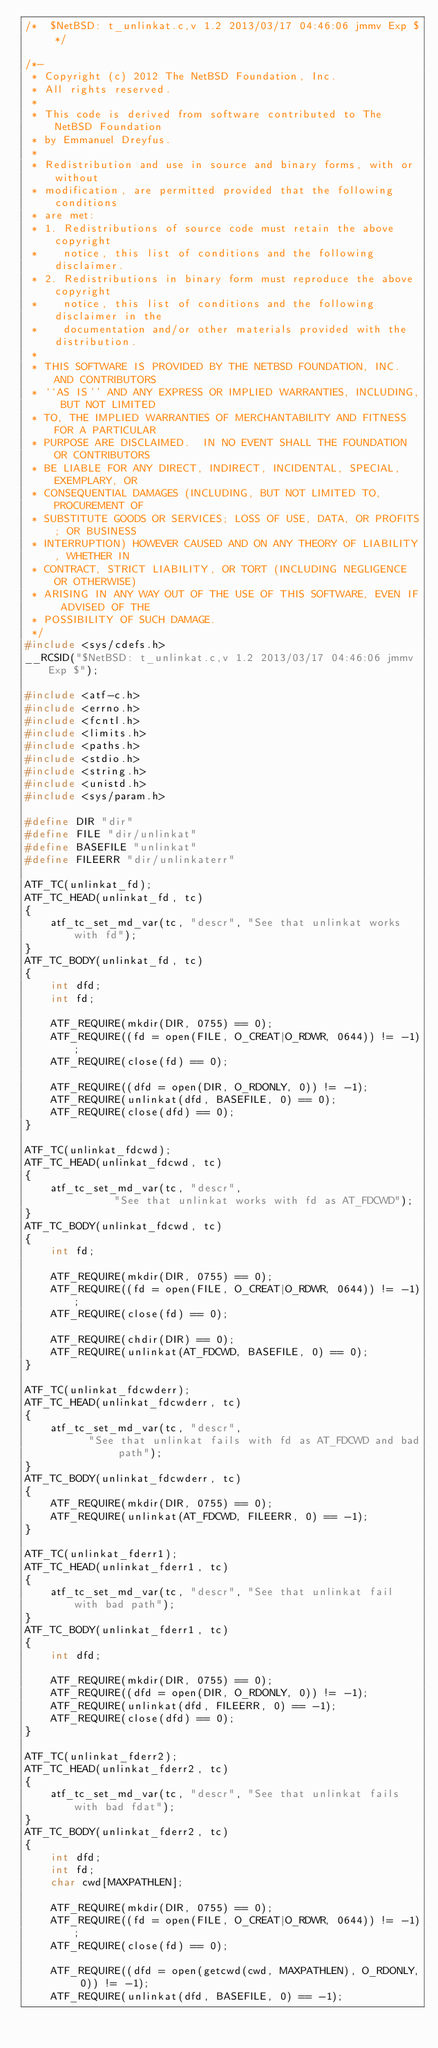<code> <loc_0><loc_0><loc_500><loc_500><_C_>/*	$NetBSD: t_unlinkat.c,v 1.2 2013/03/17 04:46:06 jmmv Exp $ */

/*-
 * Copyright (c) 2012 The NetBSD Foundation, Inc.
 * All rights reserved.
 *
 * This code is derived from software contributed to The NetBSD Foundation
 * by Emmanuel Dreyfus.
 *
 * Redistribution and use in source and binary forms, with or without
 * modification, are permitted provided that the following conditions
 * are met:
 * 1. Redistributions of source code must retain the above copyright
 *    notice, this list of conditions and the following disclaimer.
 * 2. Redistributions in binary form must reproduce the above copyright
 *    notice, this list of conditions and the following disclaimer in the
 *    documentation and/or other materials provided with the distribution.
 *
 * THIS SOFTWARE IS PROVIDED BY THE NETBSD FOUNDATION, INC. AND CONTRIBUTORS
 * ``AS IS'' AND ANY EXPRESS OR IMPLIED WARRANTIES, INCLUDING, BUT NOT LIMITED
 * TO, THE IMPLIED WARRANTIES OF MERCHANTABILITY AND FITNESS FOR A PARTICULAR
 * PURPOSE ARE DISCLAIMED.  IN NO EVENT SHALL THE FOUNDATION OR CONTRIBUTORS
 * BE LIABLE FOR ANY DIRECT, INDIRECT, INCIDENTAL, SPECIAL, EXEMPLARY, OR
 * CONSEQUENTIAL DAMAGES (INCLUDING, BUT NOT LIMITED TO, PROCUREMENT OF
 * SUBSTITUTE GOODS OR SERVICES; LOSS OF USE, DATA, OR PROFITS; OR BUSINESS
 * INTERRUPTION) HOWEVER CAUSED AND ON ANY THEORY OF LIABILITY, WHETHER IN
 * CONTRACT, STRICT LIABILITY, OR TORT (INCLUDING NEGLIGENCE OR OTHERWISE)
 * ARISING IN ANY WAY OUT OF THE USE OF THIS SOFTWARE, EVEN IF ADVISED OF THE
 * POSSIBILITY OF SUCH DAMAGE.
 */
#include <sys/cdefs.h>
__RCSID("$NetBSD: t_unlinkat.c,v 1.2 2013/03/17 04:46:06 jmmv Exp $");

#include <atf-c.h>
#include <errno.h>
#include <fcntl.h>
#include <limits.h>
#include <paths.h>
#include <stdio.h>
#include <string.h>
#include <unistd.h>
#include <sys/param.h>

#define DIR "dir"
#define FILE "dir/unlinkat"
#define BASEFILE "unlinkat"
#define FILEERR "dir/unlinkaterr"

ATF_TC(unlinkat_fd);
ATF_TC_HEAD(unlinkat_fd, tc)
{
	atf_tc_set_md_var(tc, "descr", "See that unlinkat works with fd");
}
ATF_TC_BODY(unlinkat_fd, tc)
{
	int dfd;
	int fd;

	ATF_REQUIRE(mkdir(DIR, 0755) == 0);
	ATF_REQUIRE((fd = open(FILE, O_CREAT|O_RDWR, 0644)) != -1);
	ATF_REQUIRE(close(fd) == 0);

	ATF_REQUIRE((dfd = open(DIR, O_RDONLY, 0)) != -1);
	ATF_REQUIRE(unlinkat(dfd, BASEFILE, 0) == 0);
	ATF_REQUIRE(close(dfd) == 0);
}

ATF_TC(unlinkat_fdcwd);
ATF_TC_HEAD(unlinkat_fdcwd, tc)
{
	atf_tc_set_md_var(tc, "descr", 
			  "See that unlinkat works with fd as AT_FDCWD");
}
ATF_TC_BODY(unlinkat_fdcwd, tc)
{
	int fd;

	ATF_REQUIRE(mkdir(DIR, 0755) == 0);
	ATF_REQUIRE((fd = open(FILE, O_CREAT|O_RDWR, 0644)) != -1);
	ATF_REQUIRE(close(fd) == 0);

	ATF_REQUIRE(chdir(DIR) == 0);
	ATF_REQUIRE(unlinkat(AT_FDCWD, BASEFILE, 0) == 0);
}

ATF_TC(unlinkat_fdcwderr);
ATF_TC_HEAD(unlinkat_fdcwderr, tc)
{
	atf_tc_set_md_var(tc, "descr", 
		  "See that unlinkat fails with fd as AT_FDCWD and bad path");
}
ATF_TC_BODY(unlinkat_fdcwderr, tc)
{
	ATF_REQUIRE(mkdir(DIR, 0755) == 0);
	ATF_REQUIRE(unlinkat(AT_FDCWD, FILEERR, 0) == -1);
}

ATF_TC(unlinkat_fderr1);
ATF_TC_HEAD(unlinkat_fderr1, tc)
{
	atf_tc_set_md_var(tc, "descr", "See that unlinkat fail with bad path");
}
ATF_TC_BODY(unlinkat_fderr1, tc)
{
	int dfd;

	ATF_REQUIRE(mkdir(DIR, 0755) == 0);
	ATF_REQUIRE((dfd = open(DIR, O_RDONLY, 0)) != -1);
	ATF_REQUIRE(unlinkat(dfd, FILEERR, 0) == -1);
	ATF_REQUIRE(close(dfd) == 0);
}

ATF_TC(unlinkat_fderr2);
ATF_TC_HEAD(unlinkat_fderr2, tc)
{
	atf_tc_set_md_var(tc, "descr", "See that unlinkat fails with bad fdat");
}
ATF_TC_BODY(unlinkat_fderr2, tc)
{
	int dfd;
	int fd;
	char cwd[MAXPATHLEN];

	ATF_REQUIRE(mkdir(DIR, 0755) == 0);
	ATF_REQUIRE((fd = open(FILE, O_CREAT|O_RDWR, 0644)) != -1);
	ATF_REQUIRE(close(fd) == 0);

	ATF_REQUIRE((dfd = open(getcwd(cwd, MAXPATHLEN), O_RDONLY, 0)) != -1);
	ATF_REQUIRE(unlinkat(dfd, BASEFILE, 0) == -1);</code> 